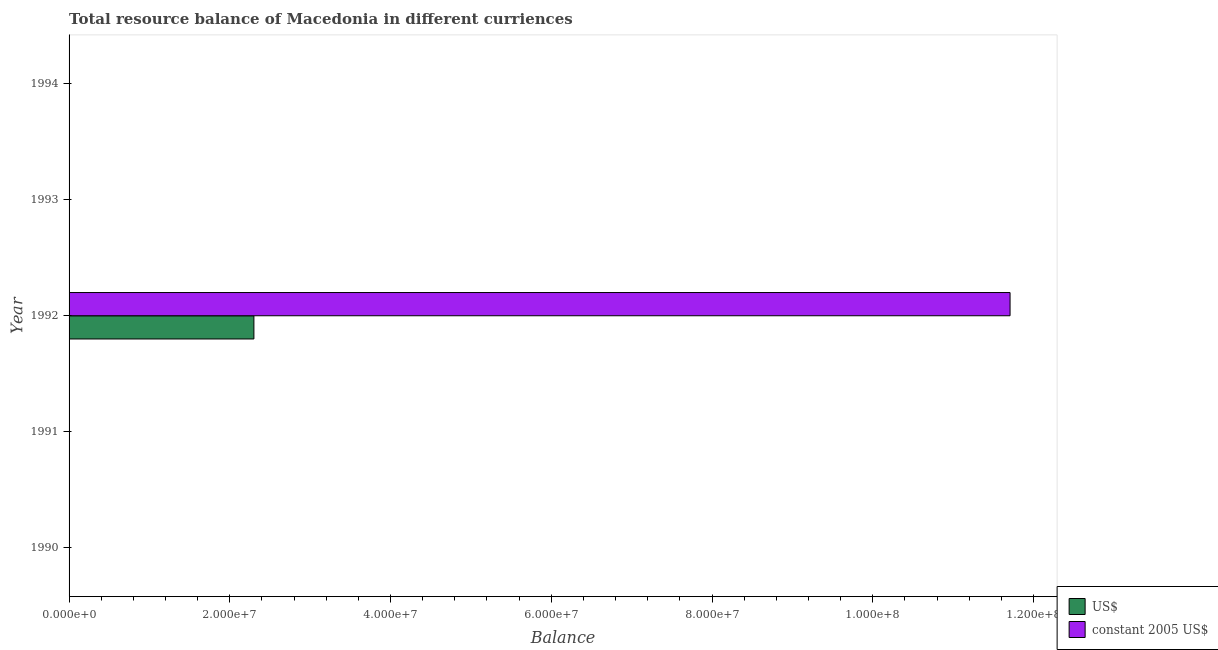What is the label of the 4th group of bars from the top?
Offer a very short reply. 1991. Across all years, what is the maximum resource balance in constant us$?
Give a very brief answer. 1.17e+08. Across all years, what is the minimum resource balance in us$?
Ensure brevity in your answer.  0. What is the total resource balance in constant us$ in the graph?
Keep it short and to the point. 1.17e+08. What is the difference between the resource balance in constant us$ in 1991 and the resource balance in us$ in 1992?
Offer a very short reply. -2.30e+07. What is the average resource balance in constant us$ per year?
Make the answer very short. 2.34e+07. In the year 1992, what is the difference between the resource balance in us$ and resource balance in constant us$?
Keep it short and to the point. -9.41e+07. What is the difference between the highest and the lowest resource balance in us$?
Provide a succinct answer. 2.30e+07. Does the graph contain any zero values?
Offer a terse response. Yes. Does the graph contain grids?
Offer a terse response. No. Where does the legend appear in the graph?
Your response must be concise. Bottom right. How many legend labels are there?
Give a very brief answer. 2. How are the legend labels stacked?
Make the answer very short. Vertical. What is the title of the graph?
Your answer should be very brief. Total resource balance of Macedonia in different curriences. Does "Import" appear as one of the legend labels in the graph?
Offer a very short reply. No. What is the label or title of the X-axis?
Your answer should be very brief. Balance. What is the Balance in US$ in 1990?
Offer a very short reply. 0. What is the Balance of constant 2005 US$ in 1990?
Your answer should be compact. 0. What is the Balance of constant 2005 US$ in 1991?
Provide a short and direct response. 0. What is the Balance of US$ in 1992?
Provide a short and direct response. 2.30e+07. What is the Balance in constant 2005 US$ in 1992?
Offer a very short reply. 1.17e+08. Across all years, what is the maximum Balance of US$?
Your answer should be compact. 2.30e+07. Across all years, what is the maximum Balance in constant 2005 US$?
Offer a very short reply. 1.17e+08. Across all years, what is the minimum Balance in constant 2005 US$?
Your response must be concise. 0. What is the total Balance in US$ in the graph?
Your answer should be very brief. 2.30e+07. What is the total Balance of constant 2005 US$ in the graph?
Your answer should be very brief. 1.17e+08. What is the average Balance in US$ per year?
Provide a short and direct response. 4.60e+06. What is the average Balance in constant 2005 US$ per year?
Your answer should be compact. 2.34e+07. In the year 1992, what is the difference between the Balance in US$ and Balance in constant 2005 US$?
Offer a terse response. -9.41e+07. What is the difference between the highest and the lowest Balance of US$?
Offer a terse response. 2.30e+07. What is the difference between the highest and the lowest Balance of constant 2005 US$?
Make the answer very short. 1.17e+08. 